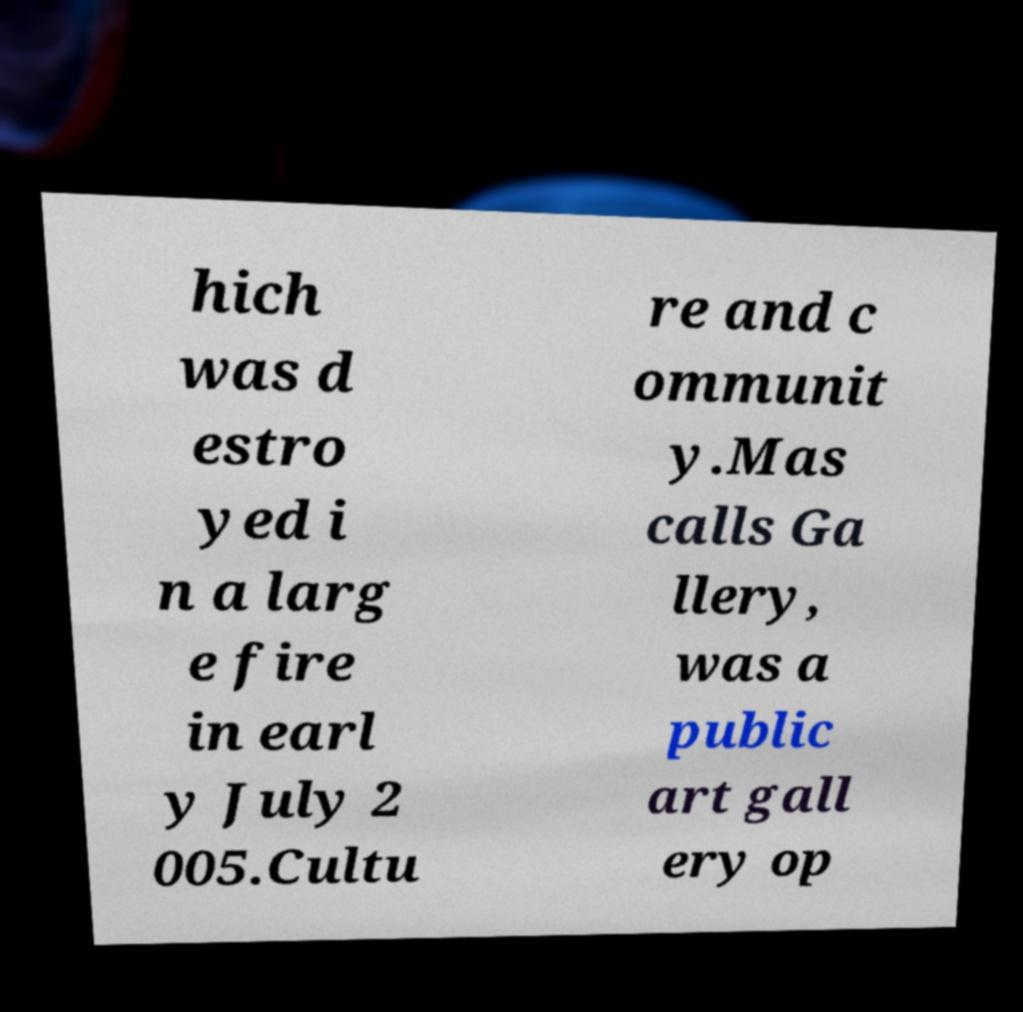For documentation purposes, I need the text within this image transcribed. Could you provide that? hich was d estro yed i n a larg e fire in earl y July 2 005.Cultu re and c ommunit y.Mas calls Ga llery, was a public art gall ery op 